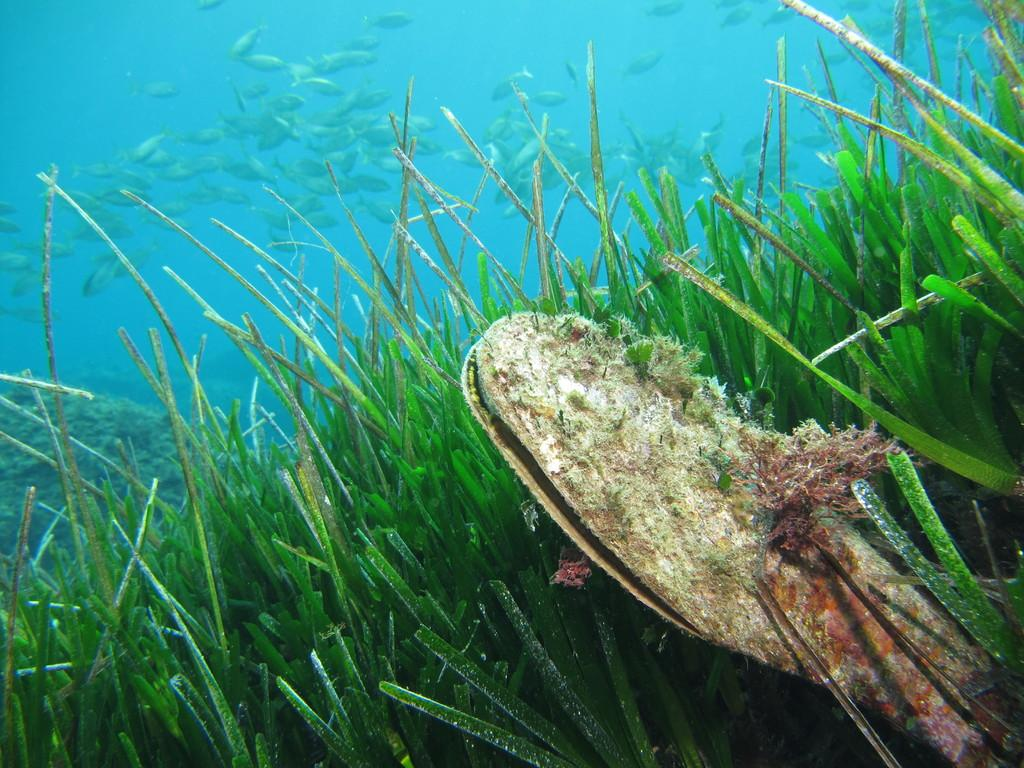What is the setting of the image? The image is underwater. What type of vegetation can be seen in the image? There is grass visible in the image. What kind of animals are present in the image? There are fish in the image. Can you describe any other objects in the water besides the grass and fish? There is at least one other object in the water, but its specific nature is not mentioned in the facts. Where is the meeting taking place in the image? There is no mention of a meeting in the image or the facts provided. What type of machine can be seen in the image? There is no machine present in the image; it is underwater with grass, fish, and at least one other object. 